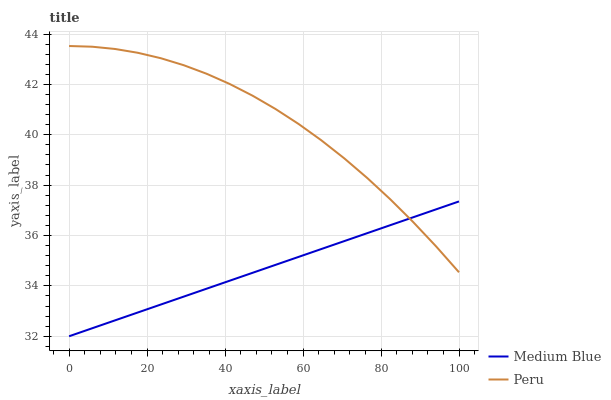Does Medium Blue have the minimum area under the curve?
Answer yes or no. Yes. Does Peru have the maximum area under the curve?
Answer yes or no. Yes. Does Peru have the minimum area under the curve?
Answer yes or no. No. Is Medium Blue the smoothest?
Answer yes or no. Yes. Is Peru the roughest?
Answer yes or no. Yes. Is Peru the smoothest?
Answer yes or no. No. Does Medium Blue have the lowest value?
Answer yes or no. Yes. Does Peru have the lowest value?
Answer yes or no. No. Does Peru have the highest value?
Answer yes or no. Yes. Does Peru intersect Medium Blue?
Answer yes or no. Yes. Is Peru less than Medium Blue?
Answer yes or no. No. Is Peru greater than Medium Blue?
Answer yes or no. No. 